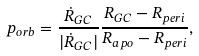Convert formula to latex. <formula><loc_0><loc_0><loc_500><loc_500>p _ { o r b } = \frac { \dot { R } _ { G C } } { | \dot { R } _ { G C } | } \frac { R _ { G C } - R _ { p e r i } } { R _ { a p o } - R _ { p e r i } } ,</formula> 